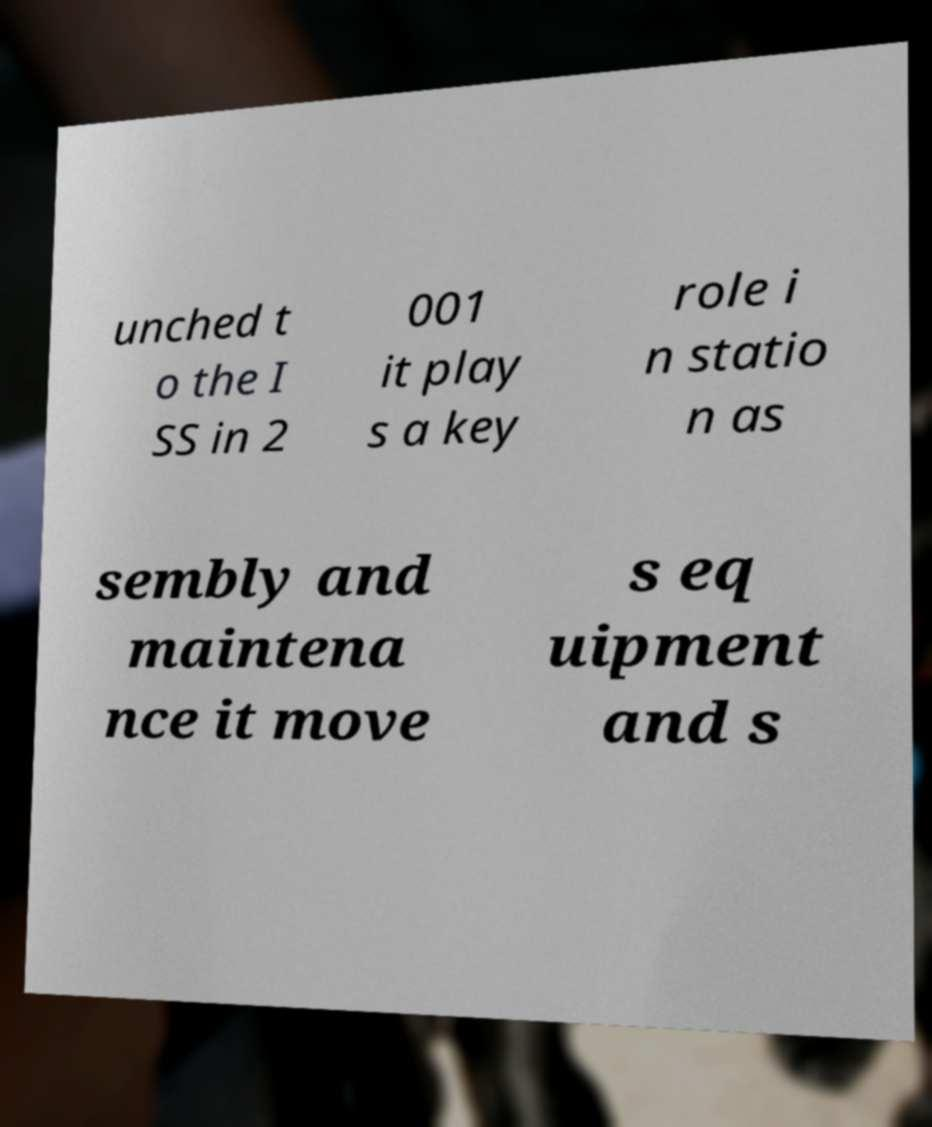Can you accurately transcribe the text from the provided image for me? unched t o the I SS in 2 001 it play s a key role i n statio n as sembly and maintena nce it move s eq uipment and s 